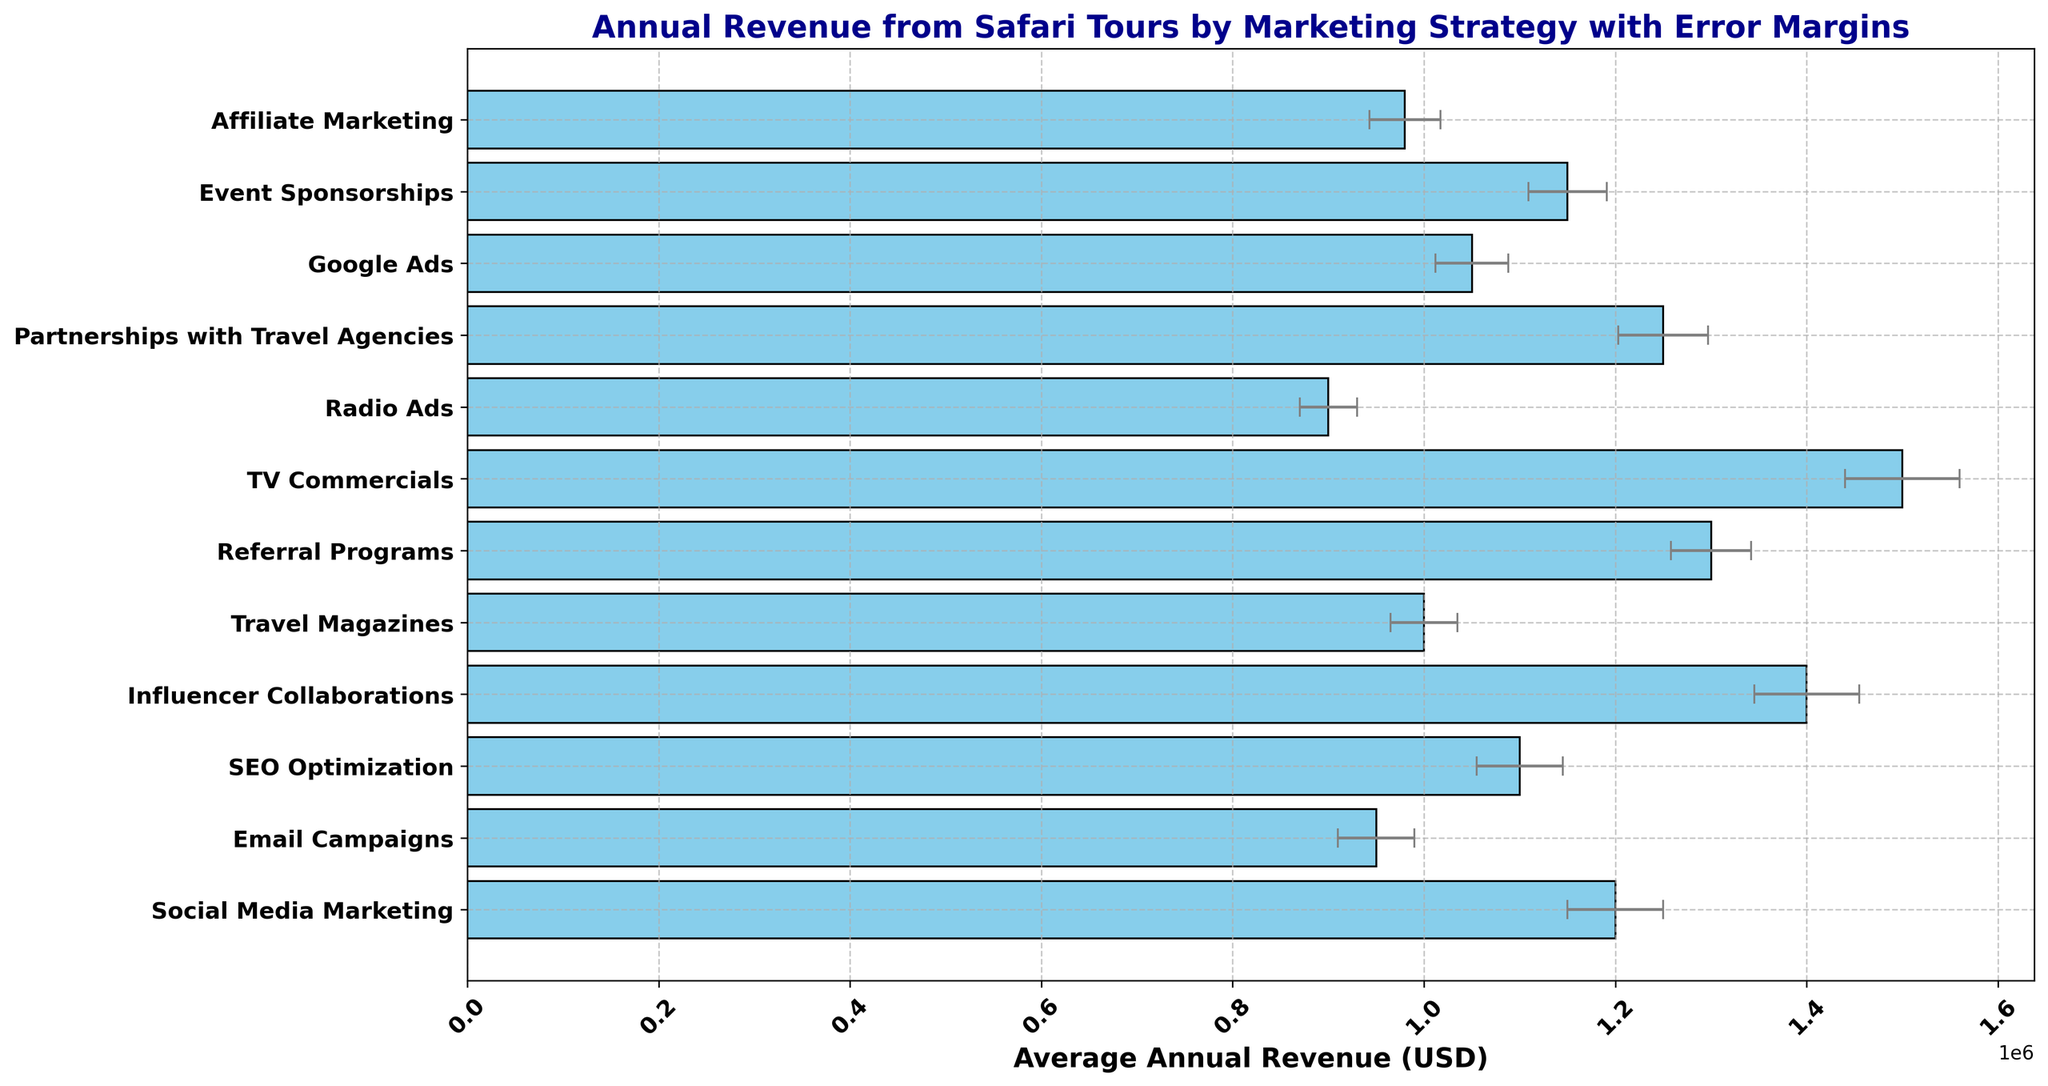Which marketing strategy generates the highest average annual revenue? The bar for 'TV Commercials' is the tallest, indicating the highest average annual revenue.
Answer: TV Commercials What is the difference in average annual revenue between Social Media Marketing and Radio Ads? The average annual revenue for Social Media Marketing is 1,200,000 USD and for Radio Ads is 900,000 USD. The difference is 1,200,000 - 900,000.
Answer: 300,000 USD Which two marketing strategies have the closest average annual revenue? The average annual revenues of Google Ads (1,050,000 USD) and SEO Optimization (1,100,000 USD) are very close to each other, with only a small difference.
Answer: Google Ads and SEO Optimization How does the error margin of Influencer Collaborations compare to that of Email Campaigns? The error margin for Influencer Collaborations is 55,000 USD, which is larger than that for Email Campaigns at 40,000 USD.
Answer: Influencer Collaborations has a larger error margin Which marketing strategy has the smallest error margin, and what is its value? The smallest error margin is for Travel Magazines, which has an error of 35,000 USD.
Answer: Travel Magazines, 35,000 USD By what percentage is the average annual revenue of TV Commercials greater than that of Email Campaigns? The average annual revenue of TV Commercials is 1,500,000 USD and that of Email Campaigns is 950,000 USD. The percentage difference is calculated as ((1,500,000 - 950,000) / 950,000) * 100%.
Answer: 57.89% What are the three marketing strategies with the highest standard error? The bars corresponding to the highest standard errors are 'TV Commercials', 'Influencer Collaborations', and 'Partnerships with Travel Agencies'. Their error values are 60,000 USD, 55,000 USD, and 47,000 USD respectively.
Answer: TV Commercials, Influencer Collaborations, Partnerships with Travel Agencies Which marketing strategy has a higher average annual revenue: Referral Programs or Affiliate Marketing? Referral Programs have an average annual revenue of 1,300,000 USD, whereas Affiliate Marketing has 980,000 USD, so Referral Programs have a higher average annual revenue.
Answer: Referral Programs What is the average annual revenue of strategies with a standard error less than 40,000 USD? The strategies with standard errors less than 40,000 USD are Radio Ads (900,000 USD), Travel Magazines (1,000,000 USD), Affiliate Marketing (980,000 USD), Google Ads (1,050,000 USD). Sum their revenues and divide by 4. Average = (900,000 + 1,000,000 + 980,000 + 1,050,000) / 4.
Answer: 982,500 USD 